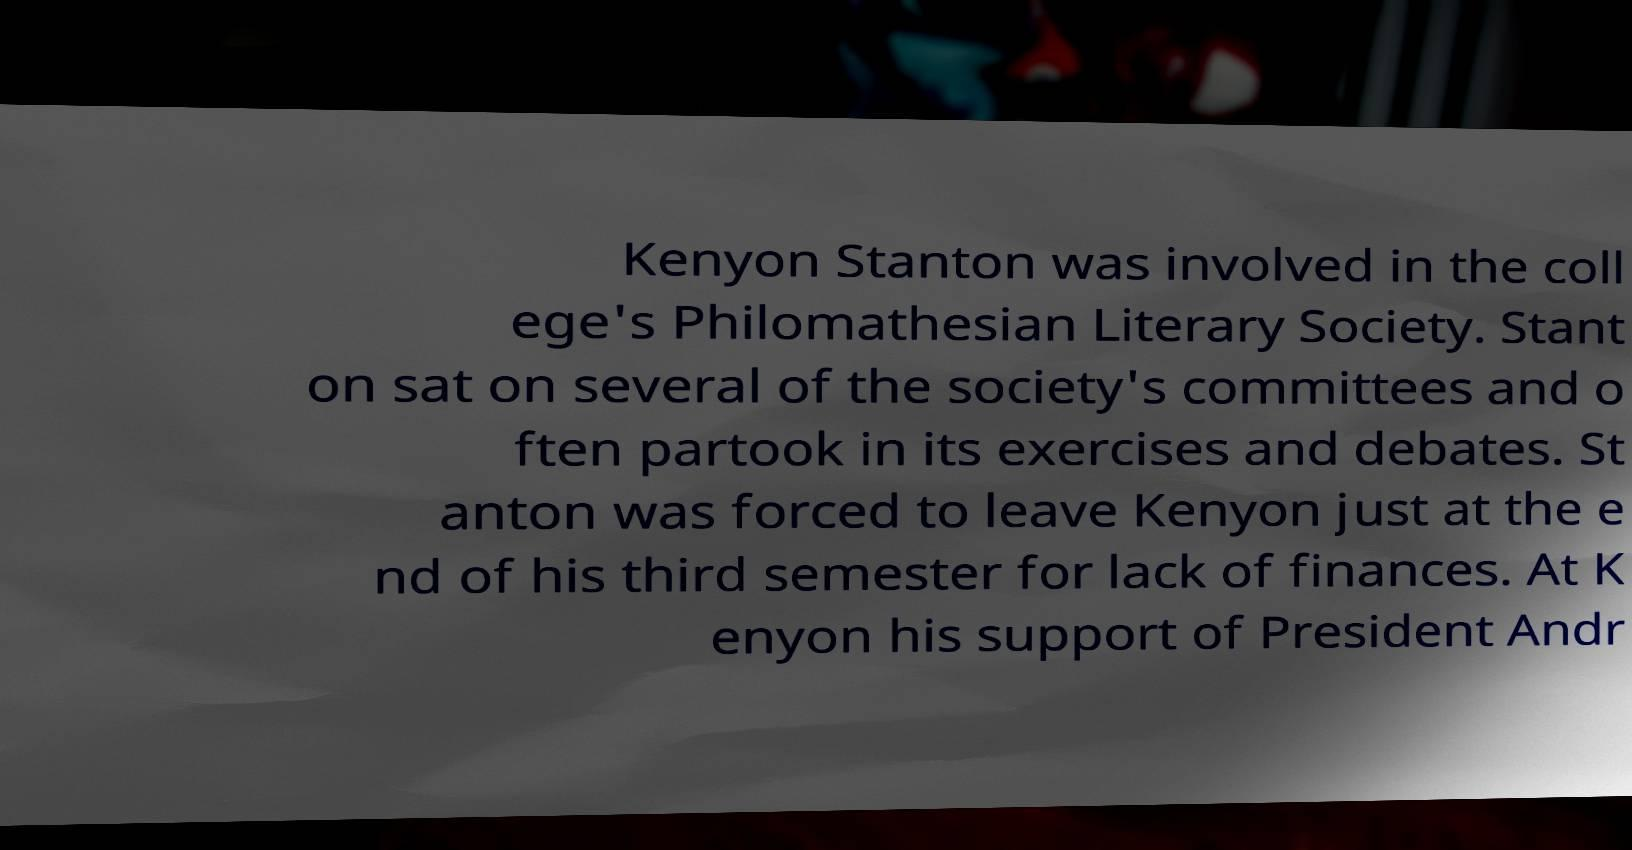There's text embedded in this image that I need extracted. Can you transcribe it verbatim? Kenyon Stanton was involved in the coll ege's Philomathesian Literary Society. Stant on sat on several of the society's committees and o ften partook in its exercises and debates. St anton was forced to leave Kenyon just at the e nd of his third semester for lack of finances. At K enyon his support of President Andr 